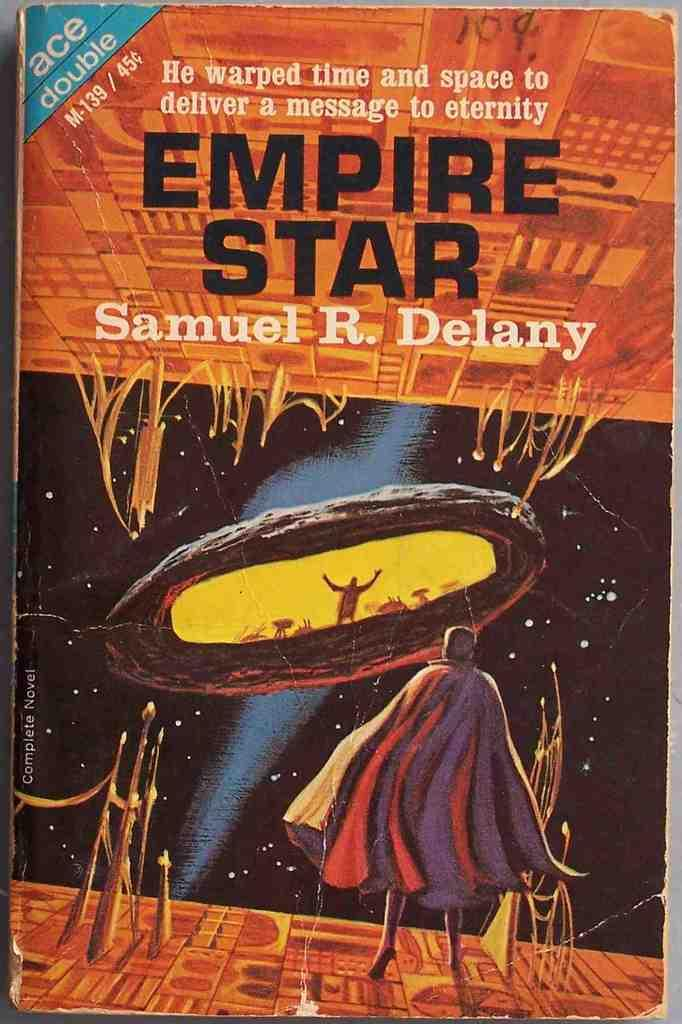<image>
Give a short and clear explanation of the subsequent image. Empire Star book by Samuel R. Delany 45cents. 